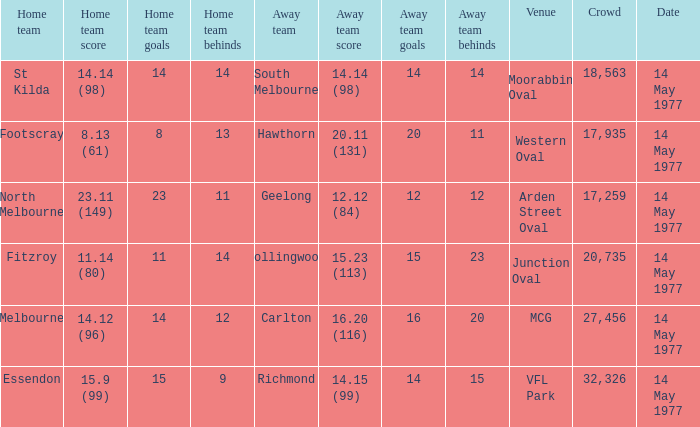Name the away team for essendon Richmond. 